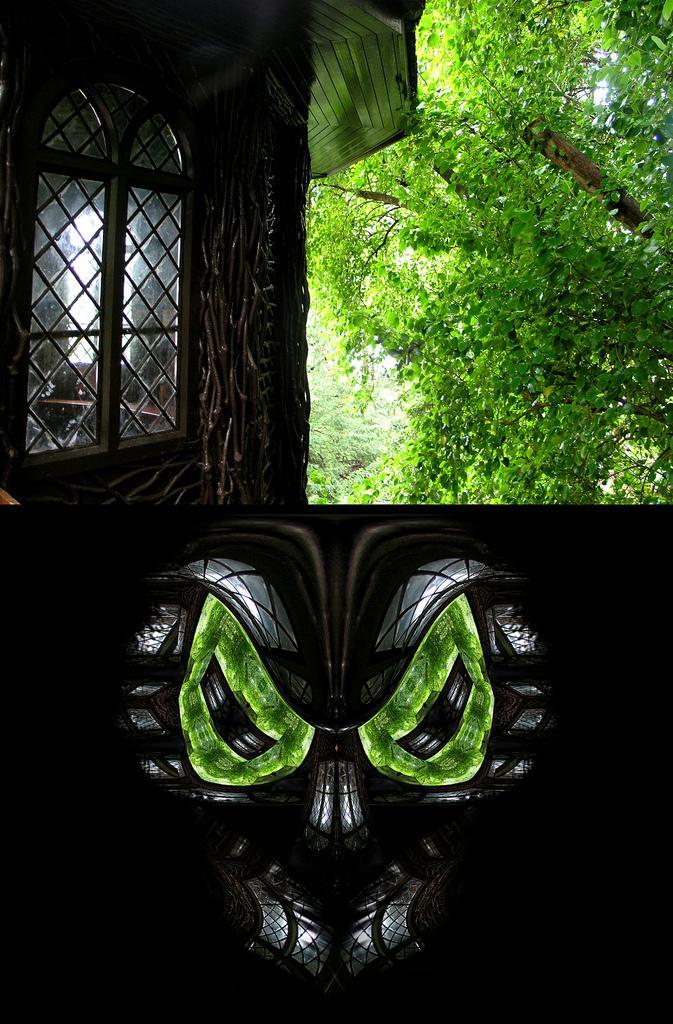Could you give a brief overview of what you see in this image? This looks like a collage picture. I think this is a face mask. This looks like a building with a window. I can see the trees. 